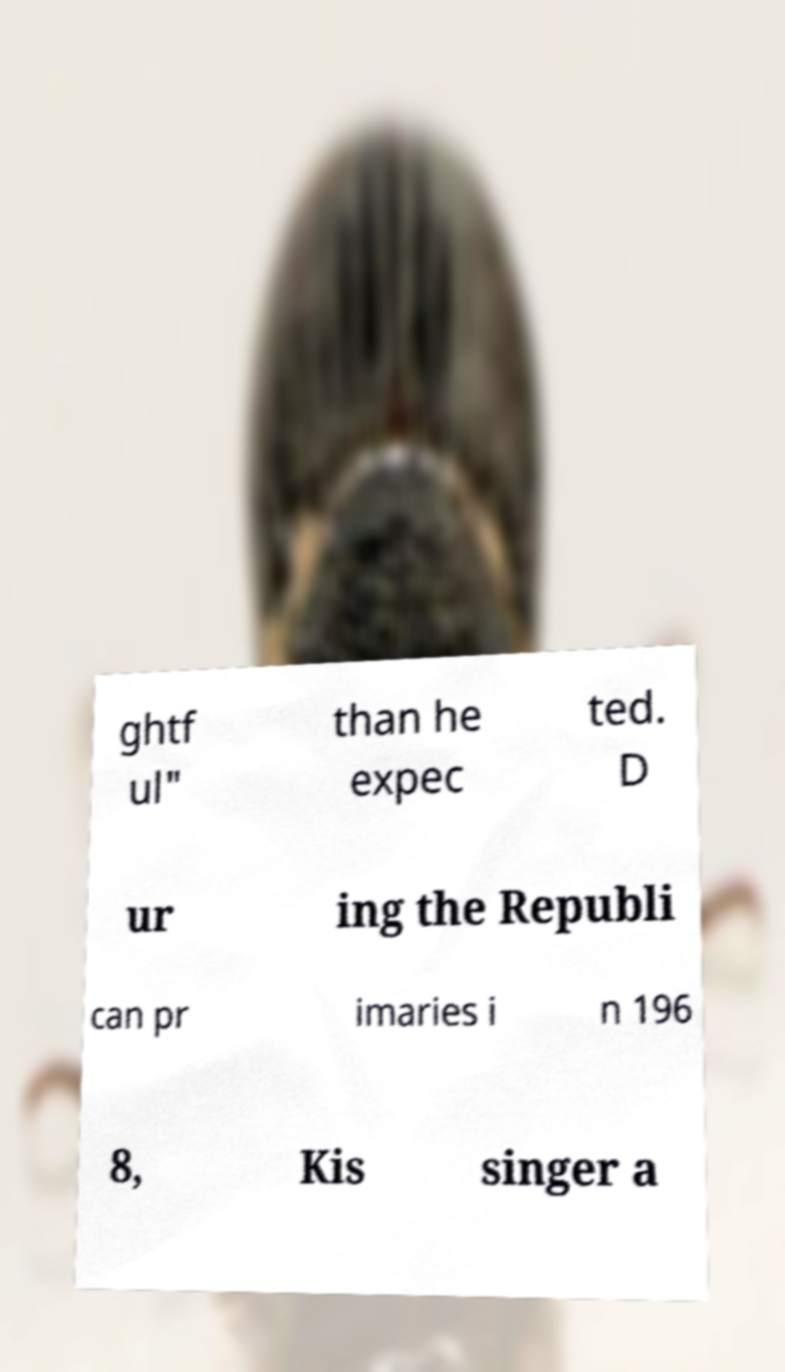Could you assist in decoding the text presented in this image and type it out clearly? ghtf ul" than he expec ted. D ur ing the Republi can pr imaries i n 196 8, Kis singer a 